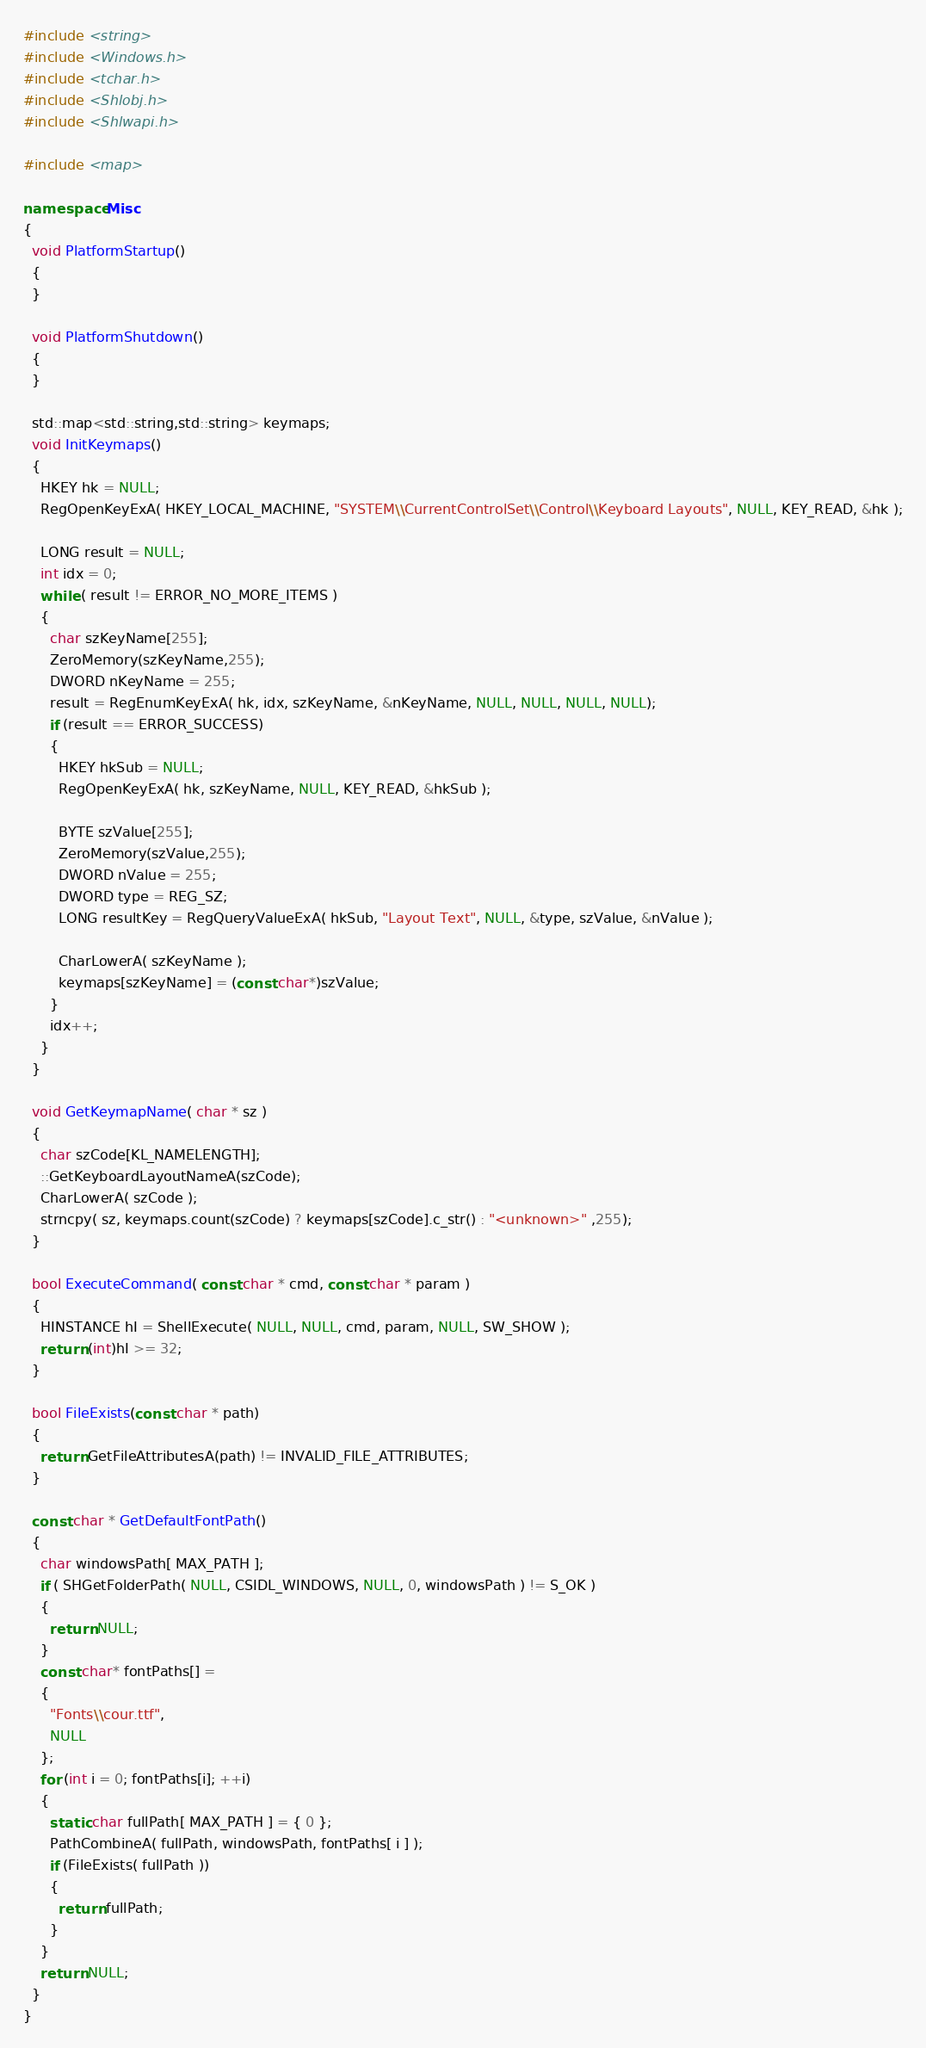Convert code to text. <code><loc_0><loc_0><loc_500><loc_500><_C++_>#include <string>
#include <Windows.h>
#include <tchar.h>
#include <Shlobj.h>
#include <Shlwapi.h>

#include <map>

namespace Misc
{
  void PlatformStartup()
  {
  }

  void PlatformShutdown()
  {
  }

  std::map<std::string,std::string> keymaps;
  void InitKeymaps()
  {
    HKEY hk = NULL;
    RegOpenKeyExA( HKEY_LOCAL_MACHINE, "SYSTEM\\CurrentControlSet\\Control\\Keyboard Layouts", NULL, KEY_READ, &hk );

    LONG result = NULL;
    int idx = 0;
    while ( result != ERROR_NO_MORE_ITEMS )
    {
      char szKeyName[255];
      ZeroMemory(szKeyName,255);
      DWORD nKeyName = 255;
      result = RegEnumKeyExA( hk, idx, szKeyName, &nKeyName, NULL, NULL, NULL, NULL);
      if (result == ERROR_SUCCESS)
      {
        HKEY hkSub = NULL;
        RegOpenKeyExA( hk, szKeyName, NULL, KEY_READ, &hkSub );

        BYTE szValue[255];
        ZeroMemory(szValue,255);
        DWORD nValue = 255;
        DWORD type = REG_SZ;
        LONG resultKey = RegQueryValueExA( hkSub, "Layout Text", NULL, &type, szValue, &nValue );

        CharLowerA( szKeyName );
        keymaps[szKeyName] = (const char*)szValue;
      }
      idx++;
    }
  }

  void GetKeymapName( char * sz )
  {
    char szCode[KL_NAMELENGTH];
    ::GetKeyboardLayoutNameA(szCode);
    CharLowerA( szCode );
    strncpy( sz, keymaps.count(szCode) ? keymaps[szCode].c_str() : "<unknown>" ,255);
  }

  bool ExecuteCommand( const char * cmd, const char * param )
  {
    HINSTANCE hI = ShellExecute( NULL, NULL, cmd, param, NULL, SW_SHOW );
    return (int)hI >= 32;
  }

  bool FileExists(const char * path)
  {
    return GetFileAttributesA(path) != INVALID_FILE_ATTRIBUTES;
  }

  const char * GetDefaultFontPath()
  {
    char windowsPath[ MAX_PATH ];
    if ( SHGetFolderPath( NULL, CSIDL_WINDOWS, NULL, 0, windowsPath ) != S_OK )
    {
      return NULL;
    }
    const char* fontPaths[] = 
    {
      "Fonts\\cour.ttf",
      NULL
    };
    for (int i = 0; fontPaths[i]; ++i)
    {
      static char fullPath[ MAX_PATH ] = { 0 };
      PathCombineA( fullPath, windowsPath, fontPaths[ i ] );
      if (FileExists( fullPath ))
      {
        return fullPath;
      }
    }
    return NULL;
  }
}</code> 